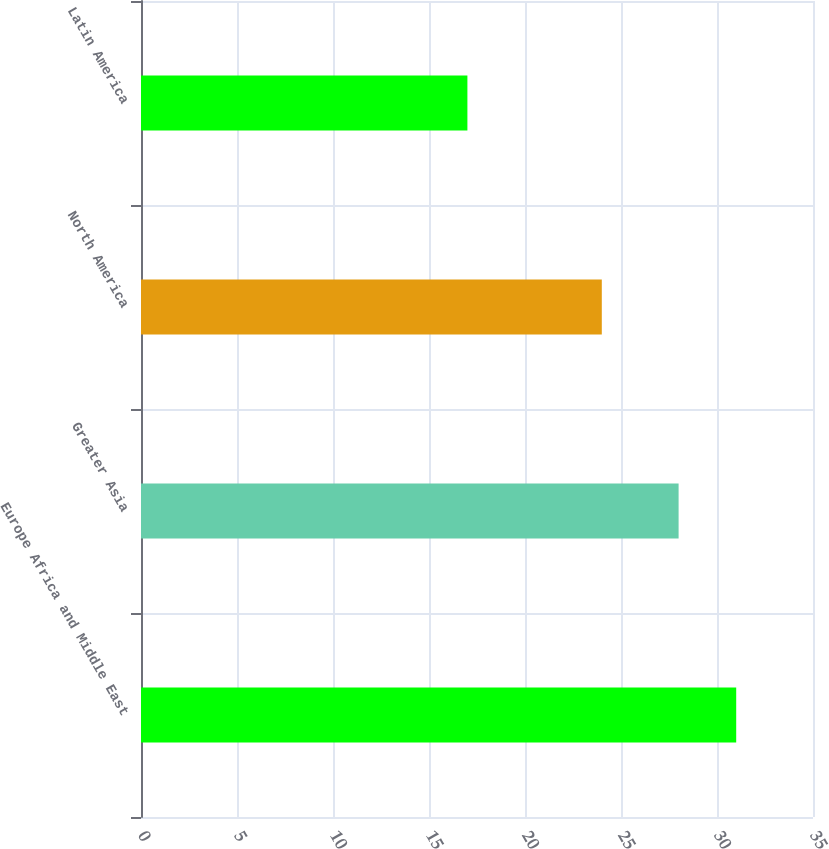<chart> <loc_0><loc_0><loc_500><loc_500><bar_chart><fcel>Europe Africa and Middle East<fcel>Greater Asia<fcel>North America<fcel>Latin America<nl><fcel>31<fcel>28<fcel>24<fcel>17<nl></chart> 